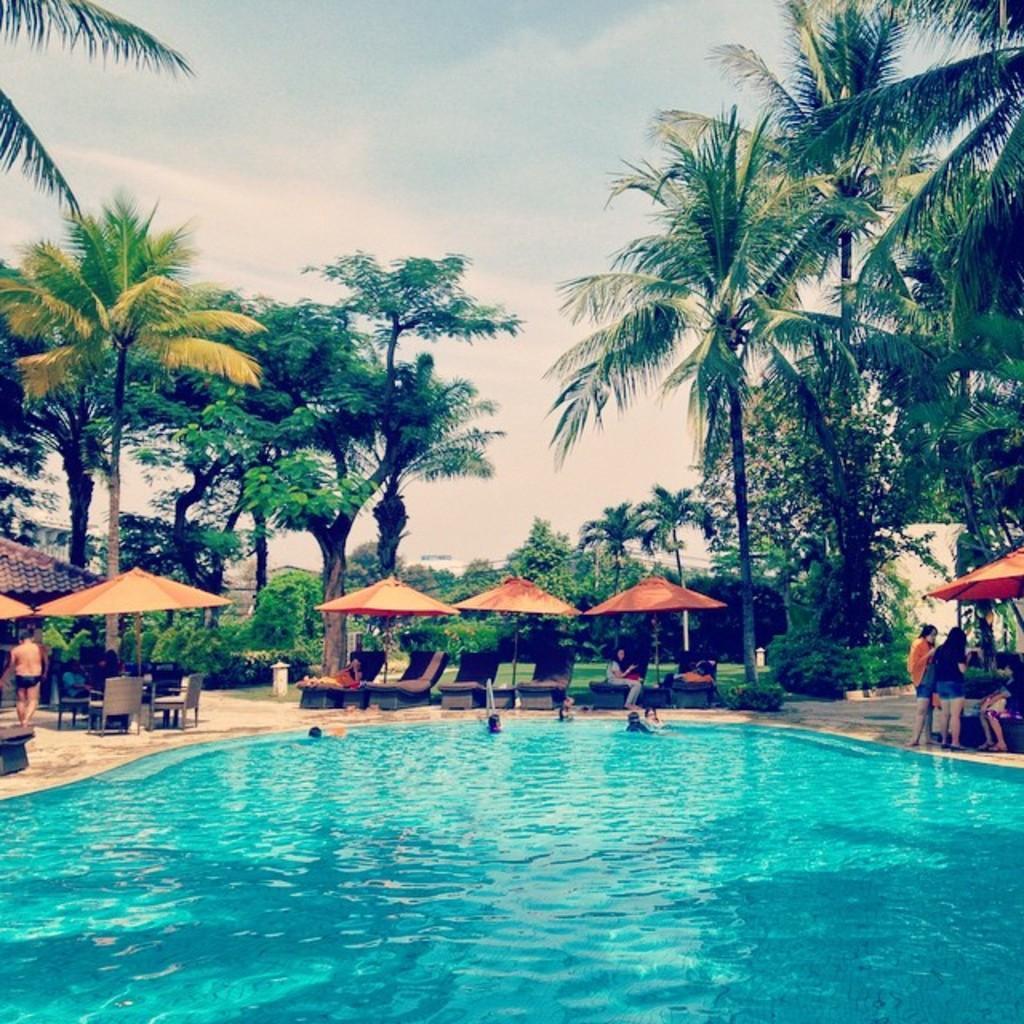In one or two sentences, can you explain what this image depicts? In this picture we can observe a swimming pool in which there are some people swimming. There are some people sitting in the chairs under the umbrellas which are in orange color. In the background there are trees and a sky with clouds. 